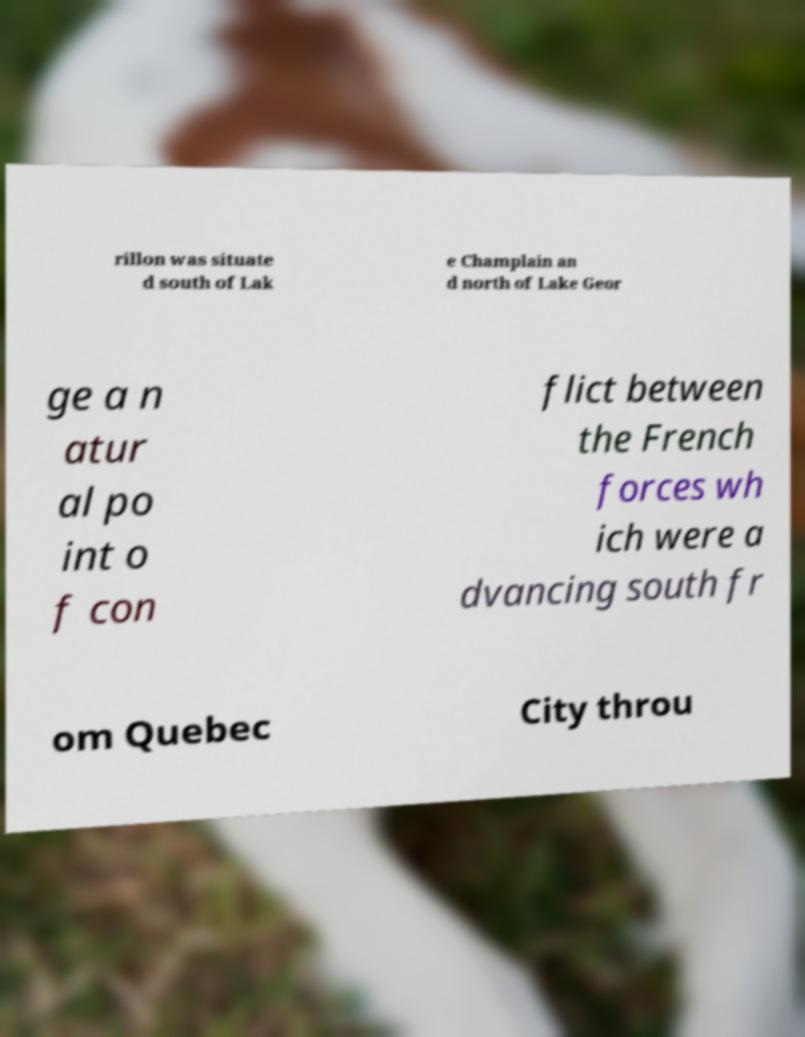I need the written content from this picture converted into text. Can you do that? rillon was situate d south of Lak e Champlain an d north of Lake Geor ge a n atur al po int o f con flict between the French forces wh ich were a dvancing south fr om Quebec City throu 